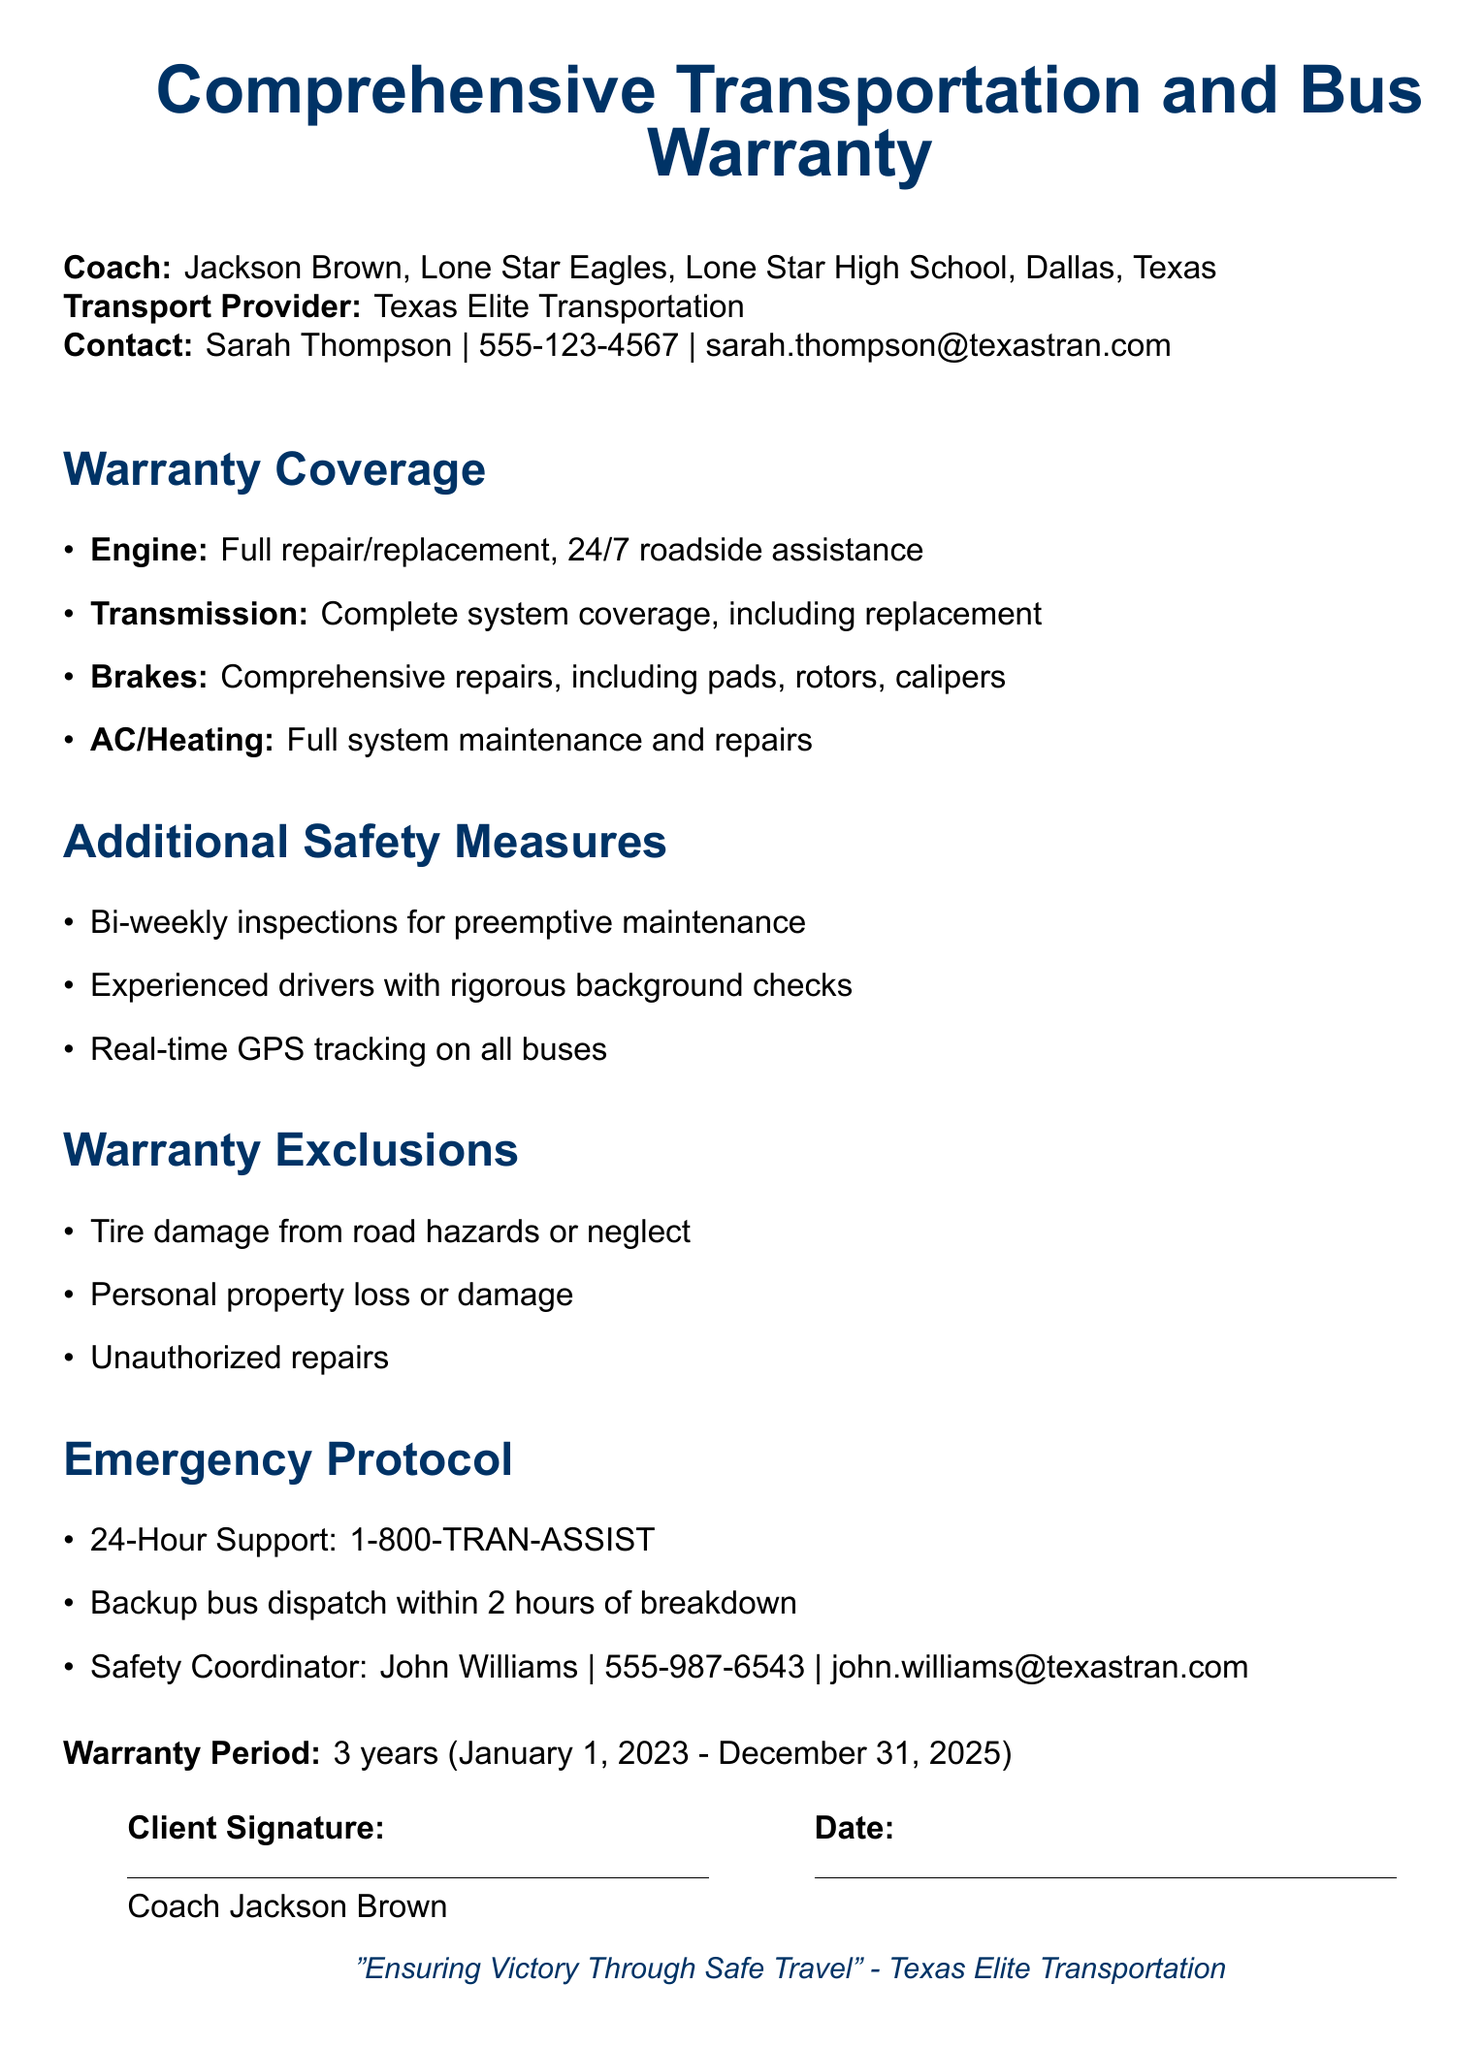What is the name of the transport provider? The transport provider listed in the document is Texas Elite Transportation.
Answer: Texas Elite Transportation What is the warranty period? The warranty period specified in the document is from January 1, 2023 to December 31, 2025.
Answer: 3 years Who is the safety coordinator? The document mentions John Williams as the safety coordinator along with his contact information.
Answer: John Williams What type of assistance is provided for the engine? The warranty states that it includes full repair/replacement and 24/7 roadside assistance.
Answer: 24/7 roadside assistance What is excluded from the warranty? The document lists tire damage from road hazards or neglect as a specific exclusion.
Answer: Tire damage What kind of inspections are performed according to the safety measures? The safety measures include bi-weekly inspections for preemptive maintenance as mentioned in the document.
Answer: Bi-weekly inspections How long does it take for a backup bus to be dispatched? According to the emergency protocol, it takes backup bus dispatch within 2 hours of breakdown.
Answer: 2 hours What is the contact number for 24-hour support? The document provides a specific number for 24-hour support, which is 1-800-TRAN-ASSIST.
Answer: 1-800-TRAN-ASSIST 